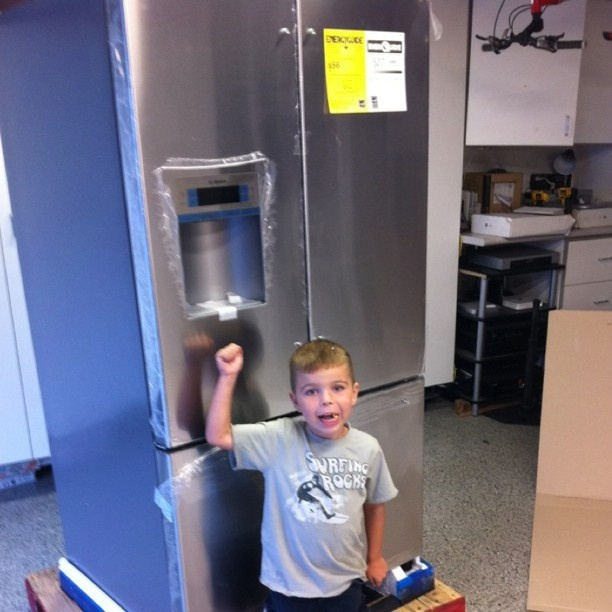Describe the objects in this image and their specific colors. I can see refrigerator in black, gray, and darkgray tones and people in black, darkgray, lightgray, and lightpink tones in this image. 